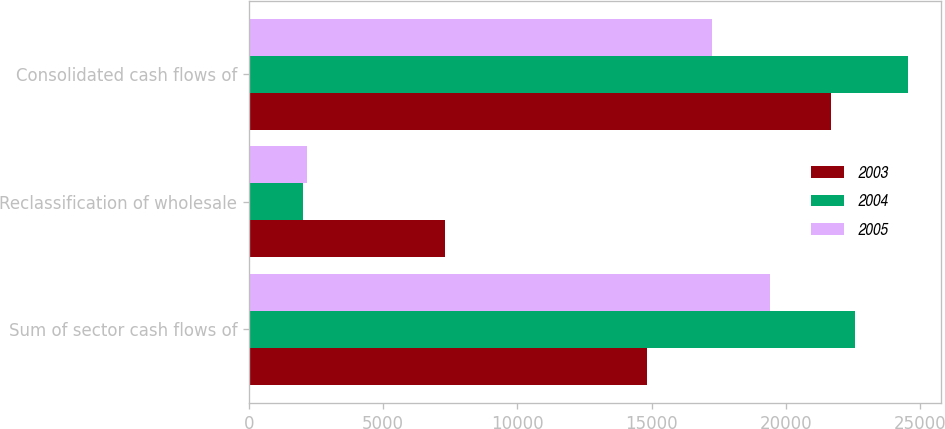Convert chart to OTSL. <chart><loc_0><loc_0><loc_500><loc_500><stacked_bar_chart><ecel><fcel>Sum of sector cash flows of<fcel>Reclassification of wholesale<fcel>Consolidated cash flows of<nl><fcel>2003<fcel>14820<fcel>7290<fcel>21674<nl><fcel>2004<fcel>22561<fcel>2001<fcel>24562<nl><fcel>2005<fcel>19410<fcel>2154<fcel>17256<nl></chart> 